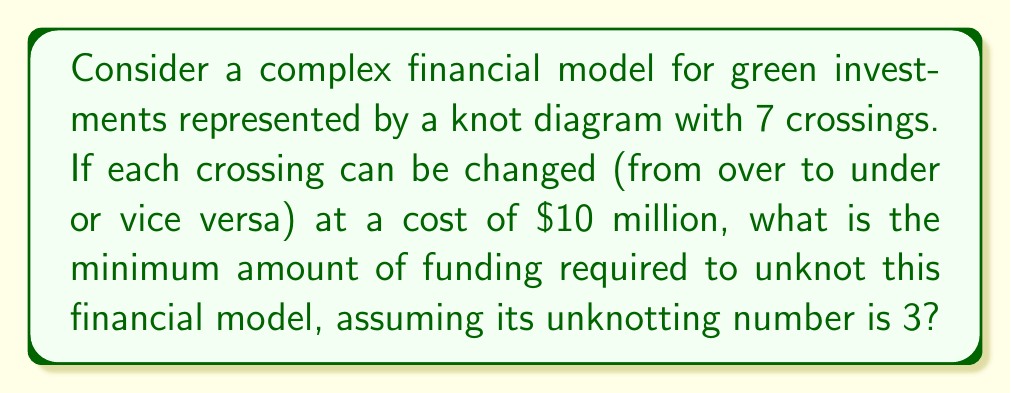Can you answer this question? To solve this problem, we need to follow these steps:

1. Understand the concept of unknotting number:
   The unknotting number is the minimum number of crossing changes required to transform a given knot into the unknot (trivial knot).

2. Identify the given information:
   - The financial model is represented by a knot with 7 crossings.
   - The unknotting number of this knot is 3.
   - Each crossing change costs $10 million.

3. Calculate the minimum funding required:
   Let $u$ be the unknotting number and $c$ be the cost per crossing change.
   The minimum funding required is given by:

   $$F_{min} = u \times c$$

   Substituting the given values:

   $$F_{min} = 3 \times \$10\text{ million}$$
   $$F_{min} = \$30\text{ million}$$

Therefore, the minimum amount of funding required to unknot this financial model is $30 million.
Answer: $30 million 